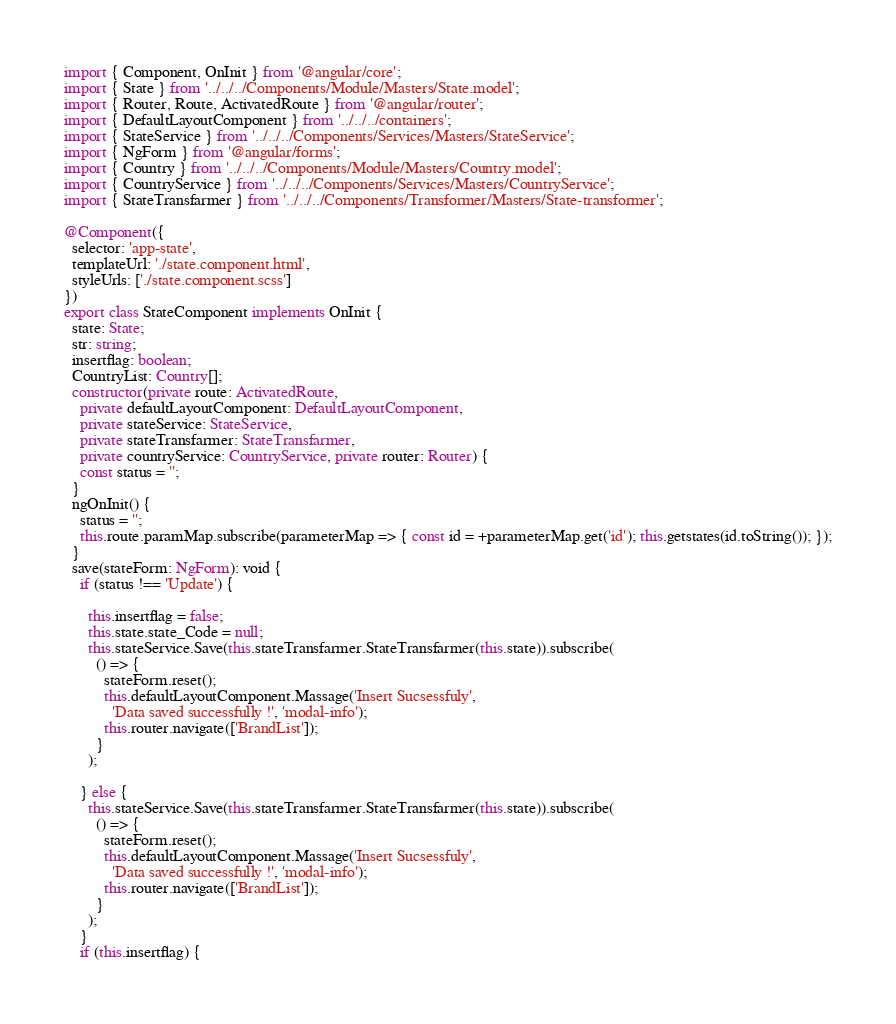<code> <loc_0><loc_0><loc_500><loc_500><_TypeScript_>import { Component, OnInit } from '@angular/core';
import { State } from '../../../Components/Module/Masters/State.model';
import { Router, Route, ActivatedRoute } from '@angular/router';
import { DefaultLayoutComponent } from '../../../containers';
import { StateService } from '../../../Components/Services/Masters/StateService';
import { NgForm } from '@angular/forms';
import { Country } from '../../../Components/Module/Masters/Country.model';
import { CountryService } from '../../../Components/Services/Masters/CountryService';
import { StateTransfarmer } from '../../../Components/Transformer/Masters/State-transformer';

@Component({
  selector: 'app-state',
  templateUrl: './state.component.html',
  styleUrls: ['./state.component.scss']
})
export class StateComponent implements OnInit {
  state: State;
  str: string;
  insertflag: boolean;
  CountryList: Country[];
  constructor(private route: ActivatedRoute,
    private defaultLayoutComponent: DefaultLayoutComponent,
    private stateService: StateService,
    private stateTransfarmer: StateTransfarmer,
    private countryService: CountryService, private router: Router) {
    const status = '';
  }
  ngOnInit() {
    status = '';
    this.route.paramMap.subscribe(parameterMap => { const id = +parameterMap.get('id'); this.getstates(id.toString()); });
  }
  save(stateForm: NgForm): void {
    if (status !== 'Update') {

      this.insertflag = false;
      this.state.state_Code = null;
      this.stateService.Save(this.stateTransfarmer.StateTransfarmer(this.state)).subscribe(
        () => {
          stateForm.reset();
          this.defaultLayoutComponent.Massage('Insert Sucsessfuly',
            'Data saved successfully !', 'modal-info');
          this.router.navigate(['BrandList']);
        }
      );

    } else {
      this.stateService.Save(this.stateTransfarmer.StateTransfarmer(this.state)).subscribe(
        () => {
          stateForm.reset();
          this.defaultLayoutComponent.Massage('Insert Sucsessfuly',
            'Data saved successfully !', 'modal-info');
          this.router.navigate(['BrandList']);
        }
      );
    }
    if (this.insertflag) {</code> 